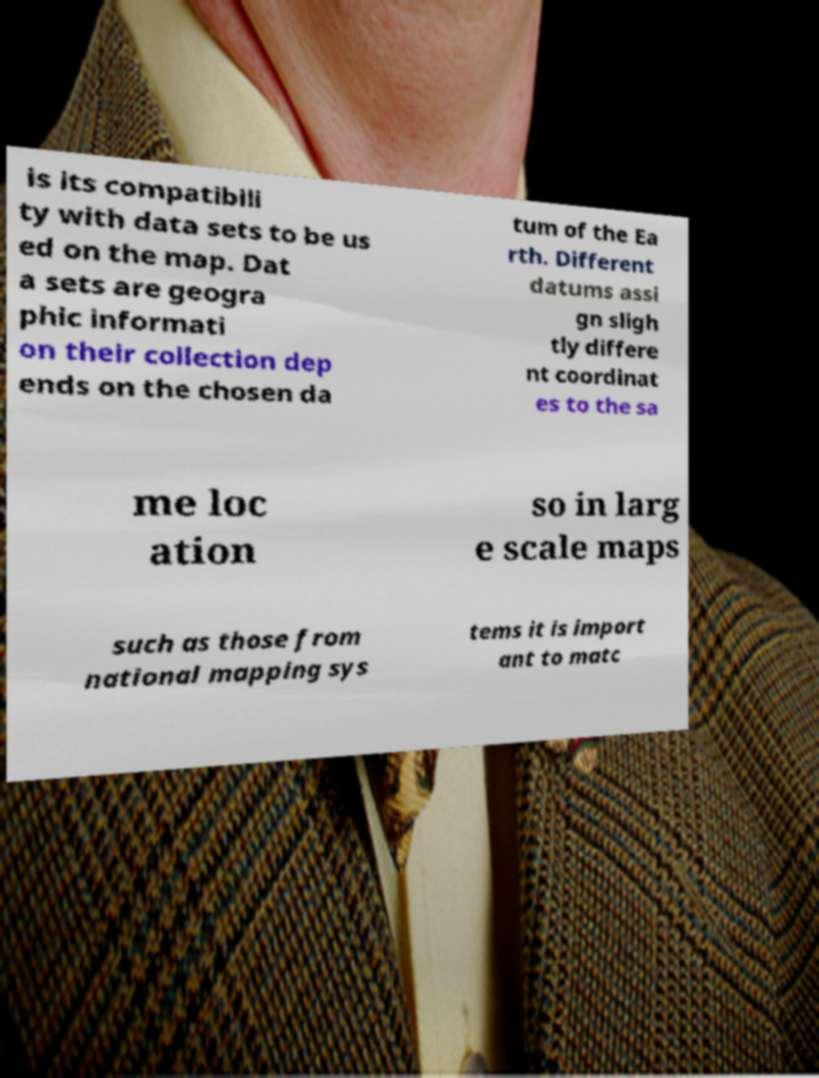Can you read and provide the text displayed in the image?This photo seems to have some interesting text. Can you extract and type it out for me? is its compatibili ty with data sets to be us ed on the map. Dat a sets are geogra phic informati on their collection dep ends on the chosen da tum of the Ea rth. Different datums assi gn sligh tly differe nt coordinat es to the sa me loc ation so in larg e scale maps such as those from national mapping sys tems it is import ant to matc 